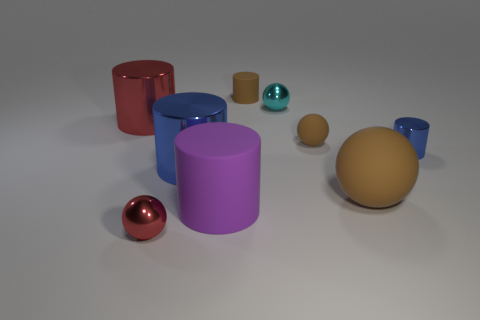Subtract all large red shiny cylinders. How many cylinders are left? 4 Subtract 2 balls. How many balls are left? 2 Subtract all cyan spheres. How many spheres are left? 3 Add 1 brown rubber spheres. How many objects exist? 10 Subtract all green spheres. Subtract all brown cylinders. How many spheres are left? 4 Subtract all spheres. How many objects are left? 5 Add 5 red shiny cylinders. How many red shiny cylinders exist? 6 Subtract 0 green cubes. How many objects are left? 9 Subtract all small cylinders. Subtract all blue cylinders. How many objects are left? 5 Add 2 blue things. How many blue things are left? 4 